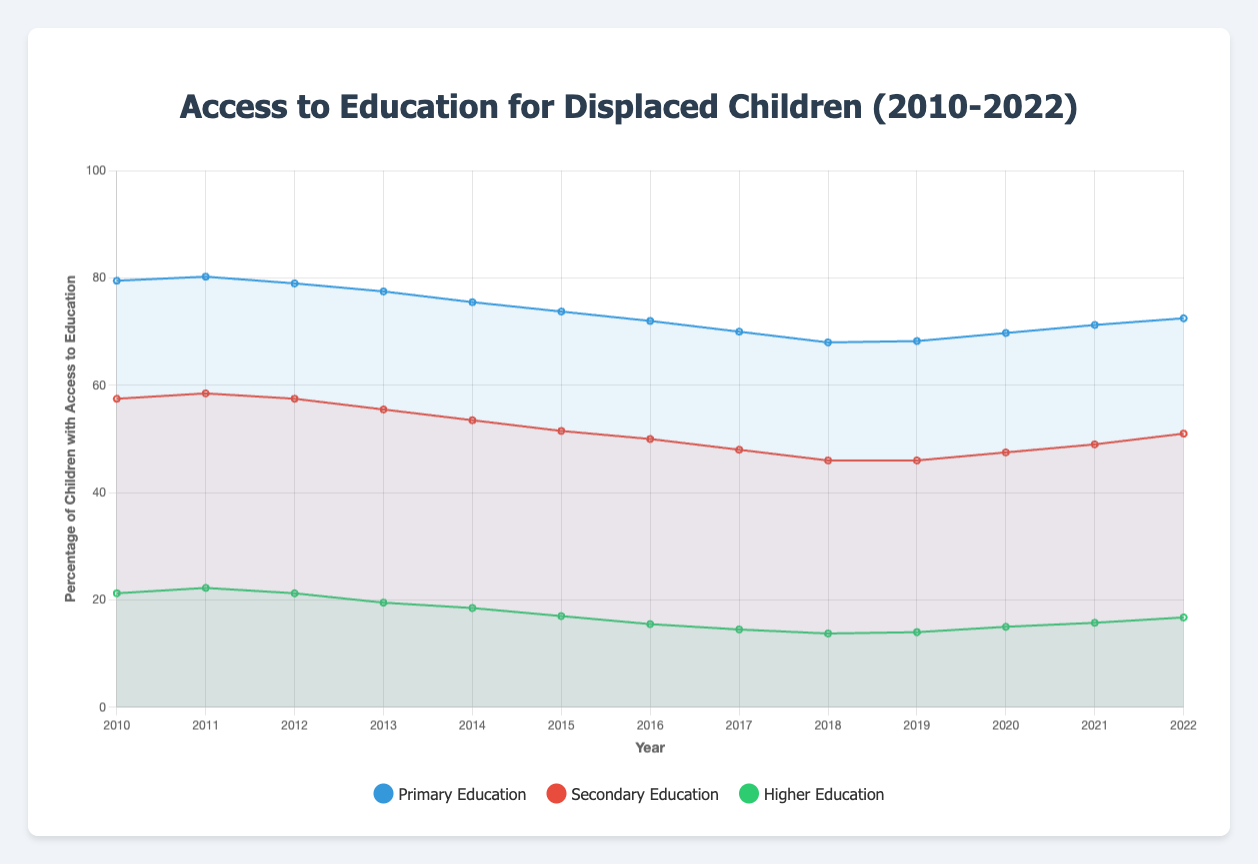What trend can be observed for primary education access in Uganda from 2010 to 2022? The line representing Uganda's primary education access on the plot shows a general decline from 2010 (starting at 65%) to 2018 (ending at 56%) with a slight recovery from 2018 to 2022 (going up to 61%).
Answer: A general decline with slight recovery towards the end Which country had the highest average access to secondary education over the period 2010-2022? To determine this, inspect the lines representing each country's secondary education access and calculate their overall average for the period. Turkey, having consistently higher values than others, shows the highest average access.
Answer: Turkey How does the trend for higher education access in Uganda compare to Jordan from 2010 to 2022? Uganda's higher education access declines sharply from 10% in 2010 to 5% in 2019 with a slight increase to 6% in 2022. Jordan shows a decline from 25% in 2010 to 18% in 2018 with a subsequent increase to 21% in 2022. Therefore, while both show decline, Uganda has sharper decreases and Jordan shows some recovery towards the end.
Answer: Uganda experienced a sharper decline, Jordan showed some recovery towards the end What is the general trend for access to primary education across all countries from 2010 to 2022? The average line for primary education from the plot shows a general declining trend from 2010 to 2022. The percentage slightly decreased over the years for most countries, indicating a consistent decline in access to primary education overall.
Answer: General decline By how much does the access to secondary education in Turkey differ from Lebanon in the year 2016? To answer, find the data points for Turkey (65%) and Lebanon (48%) for 2016. Subtract Lebanon's value from Turkey's value: 65% - 48% = 17%.
Answer: 17% Which country shows the most significant decline in higher education access from 2010 to 2022? Inspect the lines representing higher education opportunities. Uganda starts at 10% in 2010 and drops to 6% in 2022, showing the most drastic decline compared to other countries.
Answer: Uganda What was the lowest percentage of children with access to secondary education in Jordan between 2010 and 2022? By checking the plot, Jordan's secondary education line hits the lowest at around 49% in 2019.
Answer: 49% If you compare the access to primary education in Turkey and Uganda in 2014, which country had higher access, and by how much? Find the data points for primary education in 2014 for Turkey (85%) and Uganda (62%). Subtract Uganda's value from Turkey's value: 85% - 62% = 23%.
Answer: Turkey by 23% What is the average percentage change in access to primary education in Lebanon between 2010 and 2022? Calculate the difference between the initial value (2010) and final value (2022): 78% - 67% = 11%. Then, find the average change over the years: 11% / 12 years = around 0.92% per year.
Answer: Around 0.92% per year Which education level shows the greatest decline in access across all countries from 2010 to 2022? Inspect the lines for primary, secondary, and higher education access. Higher education shows the greatest decline overall, especially considering the drastic decreases in countries like Uganda.
Answer: Higher education 